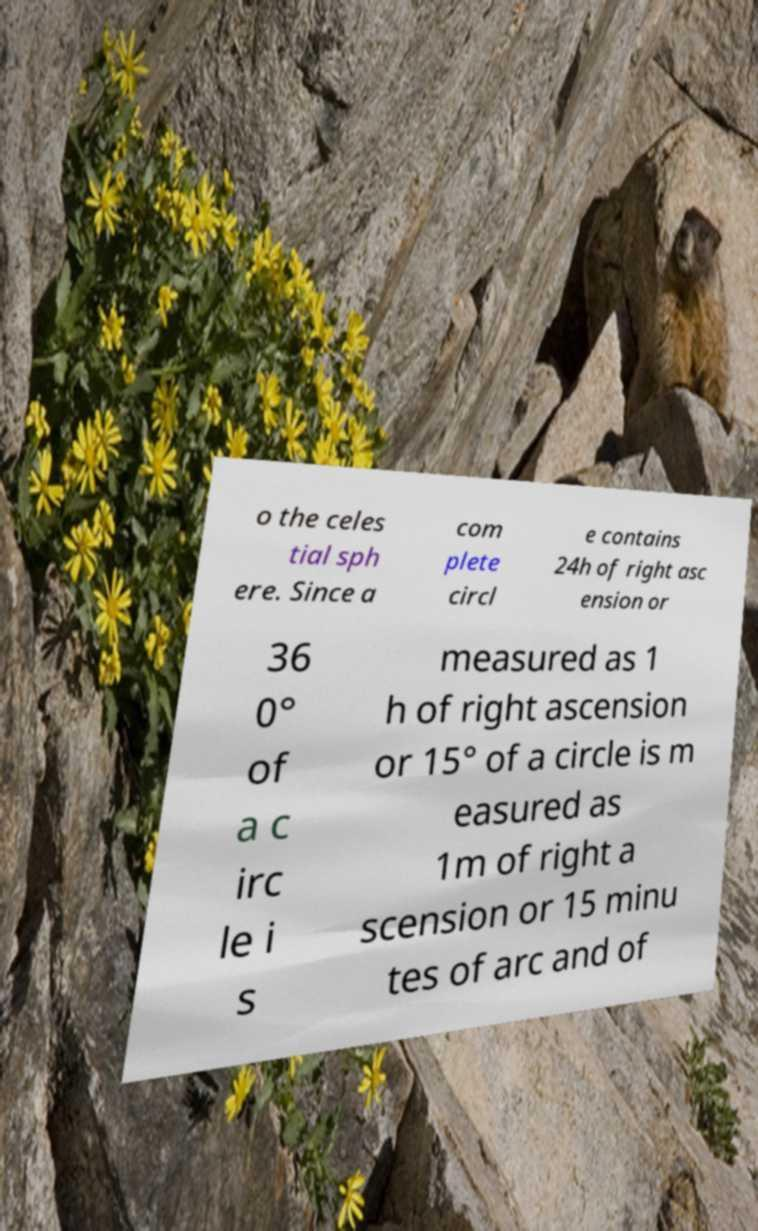Could you extract and type out the text from this image? o the celes tial sph ere. Since a com plete circl e contains 24h of right asc ension or 36 0° of a c irc le i s measured as 1 h of right ascension or 15° of a circle is m easured as 1m of right a scension or 15 minu tes of arc and of 